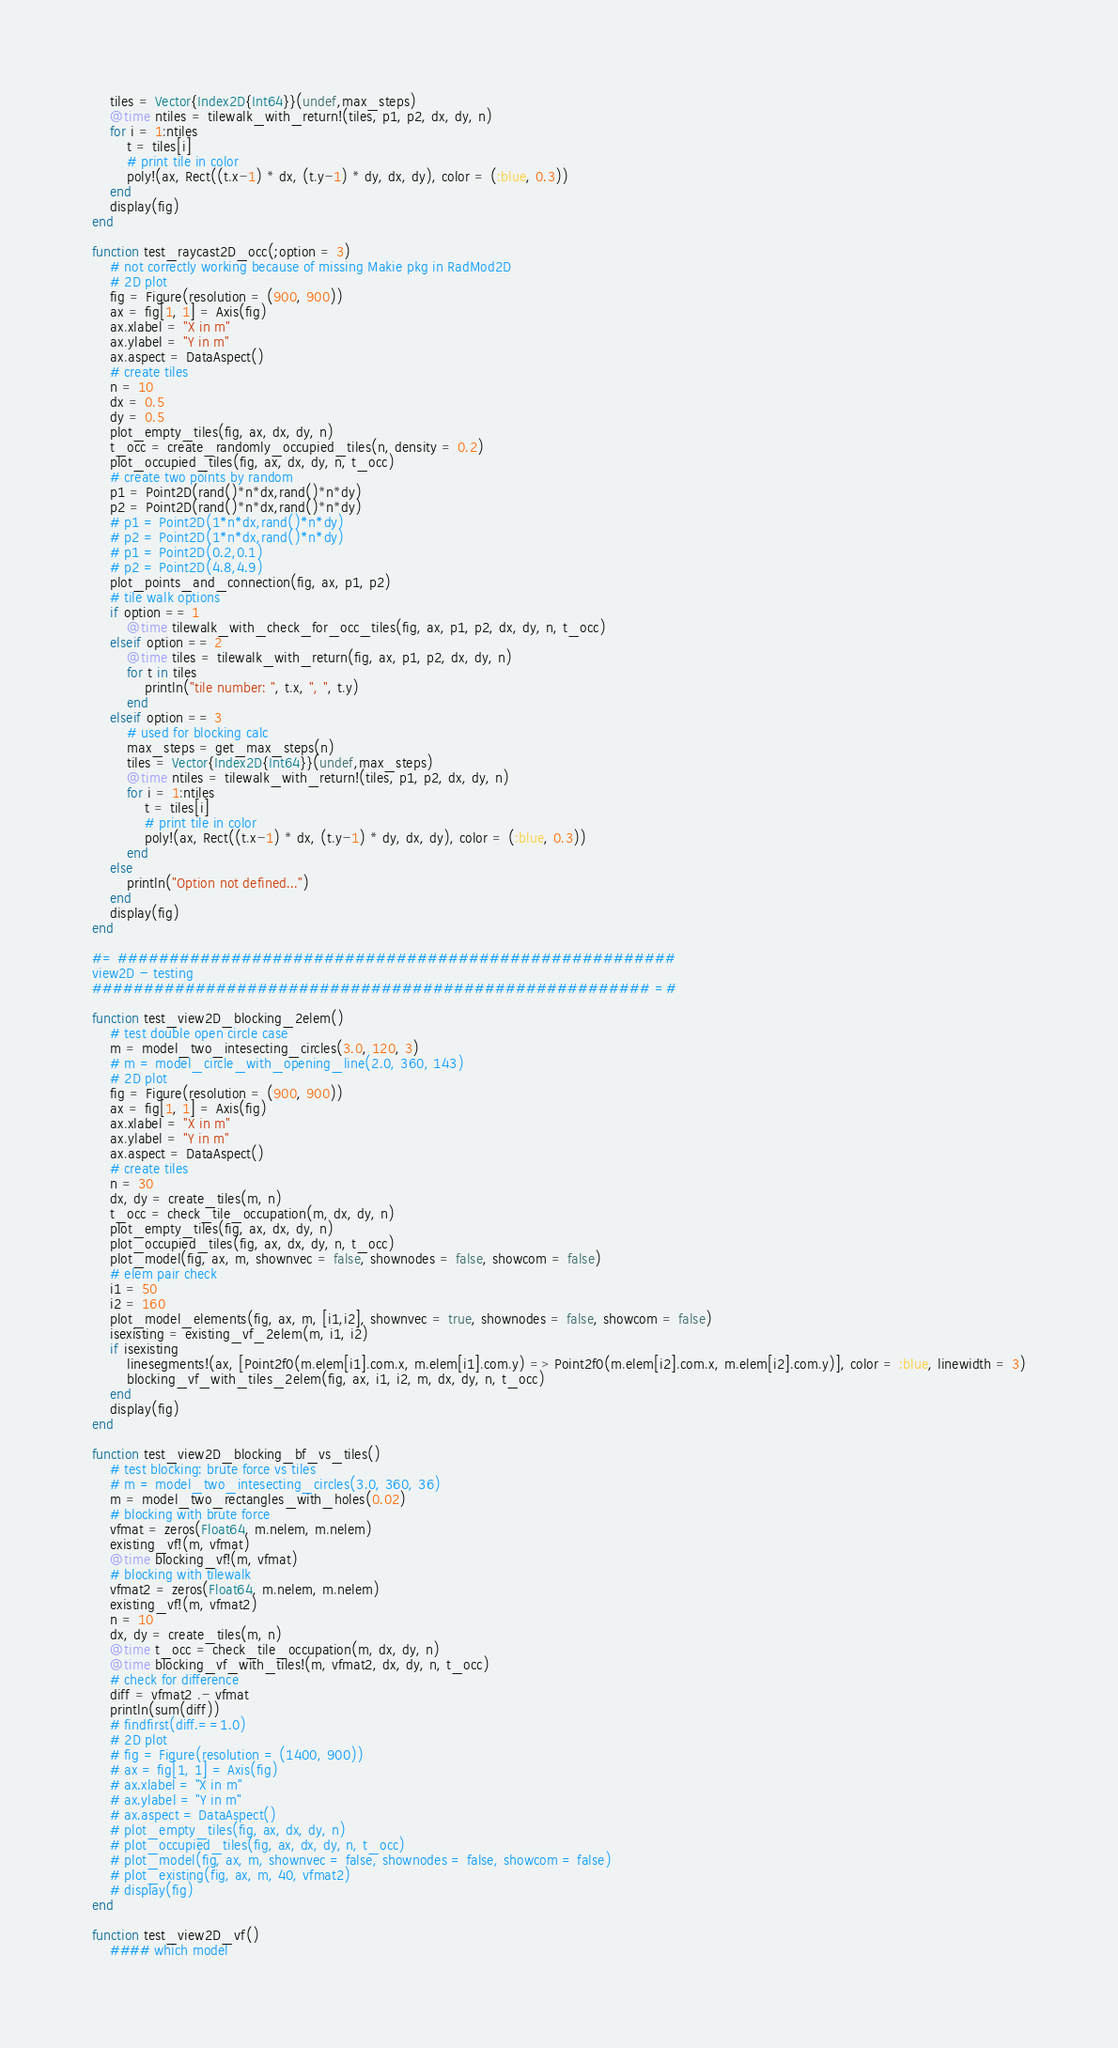Convert code to text. <code><loc_0><loc_0><loc_500><loc_500><_Julia_>    tiles = Vector{Index2D{Int64}}(undef,max_steps)
    @time ntiles = tilewalk_with_return!(tiles, p1, p2, dx, dy, n)
    for i = 1:ntiles
        t = tiles[i]
        # print tile in color
        poly!(ax, Rect((t.x-1) * dx, (t.y-1) * dy, dx, dy), color = (:blue, 0.3))
    end
    display(fig)
end

function test_raycast2D_occ(;option = 3)
    # not correctly working because of missing Makie pkg in RadMod2D
    # 2D plot
    fig = Figure(resolution = (900, 900))
    ax = fig[1, 1] = Axis(fig)
    ax.xlabel = "X in m"
    ax.ylabel = "Y in m"
    ax.aspect = DataAspect()
    # create tiles
    n = 10
    dx = 0.5
    dy = 0.5
    plot_empty_tiles(fig, ax, dx, dy, n)
    t_occ = create_randomly_occupied_tiles(n, density = 0.2)
    plot_occupied_tiles(fig, ax, dx, dy, n, t_occ)
    # create two points by random
    p1 = Point2D(rand()*n*dx,rand()*n*dy)
    p2 = Point2D(rand()*n*dx,rand()*n*dy)
    # p1 = Point2D(1*n*dx,rand()*n*dy)
    # p2 = Point2D(1*n*dx,rand()*n*dy)
    # p1 = Point2D(0.2,0.1)
    # p2 = Point2D(4.8,4.9)
    plot_points_and_connection(fig, ax, p1, p2)
    # tile walk options
    if option == 1
        @time tilewalk_with_check_for_occ_tiles(fig, ax, p1, p2, dx, dy, n, t_occ)
    elseif option == 2
        @time tiles = tilewalk_with_return(fig, ax, p1, p2, dx, dy, n)
        for t in tiles
            println("tile number: ", t.x, ", ", t.y)
        end
    elseif option == 3
        # used for blocking calc
        max_steps = get_max_steps(n)
        tiles = Vector{Index2D{Int64}}(undef,max_steps)
        @time ntiles = tilewalk_with_return!(tiles, p1, p2, dx, dy, n)
        for i = 1:ntiles
            t = tiles[i]
            # print tile in color
            poly!(ax, Rect((t.x-1) * dx, (t.y-1) * dy, dx, dy), color = (:blue, 0.3))
        end
    else
        println("Option not defined...")
    end
    display(fig)
end

#= ######################################################
view2D - testing
###################################################### =# 

function test_view2D_blocking_2elem()
    # test double open circle case
    m = model_two_intesecting_circles(3.0, 120, 3)
    # m = model_circle_with_opening_line(2.0, 360, 143)
    # 2D plot
    fig = Figure(resolution = (900, 900))
    ax = fig[1, 1] = Axis(fig)
    ax.xlabel = "X in m"
    ax.ylabel = "Y in m"
    ax.aspect = DataAspect()
    # create tiles
    n = 30
    dx, dy = create_tiles(m, n)
    t_occ = check_tile_occupation(m, dx, dy, n)
    plot_empty_tiles(fig, ax, dx, dy, n)
    plot_occupied_tiles(fig, ax, dx, dy, n, t_occ)
    plot_model(fig, ax, m, shownvec = false, shownodes = false, showcom = false)
    # elem pair check
    i1 = 50
    i2 = 160
    plot_model_elements(fig, ax, m, [i1,i2], shownvec = true, shownodes = false, showcom = false)
    isexisting = existing_vf_2elem(m, i1, i2)
    if isexisting
        linesegments!(ax, [Point2f0(m.elem[i1].com.x, m.elem[i1].com.y) => Point2f0(m.elem[i2].com.x, m.elem[i2].com.y)], color = :blue, linewidth = 3)
        blocking_vf_with_tiles_2elem(fig, ax, i1, i2, m, dx, dy, n, t_occ)
    end
    display(fig)
end

function test_view2D_blocking_bf_vs_tiles()
    # test blocking: brute force vs tiles
    # m = model_two_intesecting_circles(3.0, 360, 36)
    m = model_two_rectangles_with_holes(0.02)
    # blocking with brute force
    vfmat = zeros(Float64, m.nelem, m.nelem)
    existing_vf!(m, vfmat)
    @time blocking_vf!(m, vfmat)
    # blocking with tilewalk
    vfmat2 = zeros(Float64, m.nelem, m.nelem)
    existing_vf!(m, vfmat2)
    n = 10
    dx, dy = create_tiles(m, n)
    @time t_occ = check_tile_occupation(m, dx, dy, n)
    @time blocking_vf_with_tiles!(m, vfmat2, dx, dy, n, t_occ)
    # check for difference
    diff = vfmat2 .- vfmat
    println(sum(diff))
    # findfirst(diff.==1.0)
    # 2D plot
    # fig = Figure(resolution = (1400, 900))
    # ax = fig[1, 1] = Axis(fig)
    # ax.xlabel = "X in m"
    # ax.ylabel = "Y in m"
    # ax.aspect = DataAspect()
    # plot_empty_tiles(fig, ax, dx, dy, n)
    # plot_occupied_tiles(fig, ax, dx, dy, n, t_occ)
    # plot_model(fig, ax, m, shownvec = false, shownodes = false, showcom = false)
    # plot_existing(fig, ax, m, 40, vfmat2)
    # display(fig)
end

function test_view2D_vf()
    #### which model</code> 